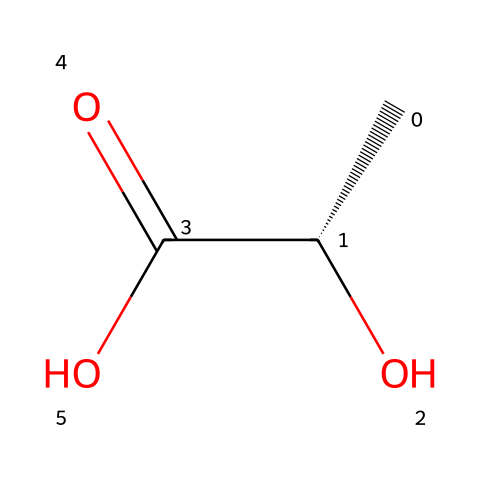What is the molecular formula of lactic acid? The SMILES representation indicates the presence of carbon (C), hydrogen (H), and oxygen (O) atoms. By counting the atoms in the formula C[C@H](O)C(=O)O, we find 3 carbon atoms, 6 hydrogen atoms, and 3 oxygen atoms. This leads to the molecular formula C3H6O3.
Answer: C3H6O3 How many chiral centers are present in lactic acid? The presence of a chiral center is indicated by the '@' symbol in the SMILES notation, specifically at the carbon atom that is attached to four different groups. There is one '@' symbol present, indicating one chiral center in lactic acid.
Answer: 1 What functional groups are present in lactic acid? Analyzing the structure, lactic acid has a hydroxyl group (–OH), a carboxylic acid (–COOH), and a methyl group (–CH3). The hydroxyl contributes to its classification as an alcohol, and the carboxylic group classifies it as an acid. Overall, these functional groups are key defining features of lactic acid.
Answer: hydroxyl and carboxylic acid What is the effect of chirality in lactic acid on its flavor profile? The chirality in lactic acid leads to different enantiomers, which can have different sensory properties including taste. Specific enantiomers may interact differently with biological receptors, thereby impacting flavor. Lactic acid's chiral nature contributes to its distinct sour taste commonly found in fermented products.
Answer: different taste How does the presence of a carboxylic acid group affect the solubility of lactic acid? The carboxylic acid group is polar and can form hydrogen bonds with water. This increased polarity enhances lactic acid's solubility in water, as polar substances generally dissolve well in polar solvents like water. Thus, the carboxylic acid group significantly boosts lactic acid's overall solubility.
Answer: increases solubility What role does lactic acid play in bourbon whiskey production? Lactic acid is produced during fermentation, and it contributes to the overall flavor complexity of bourbon whiskey. It imparts a slightly sour flavor and promotes the development of various aromatic compounds, enhancing the whiskey's taste profile. This fermentation process is crucial for the final product's character.
Answer: flavor contribution 